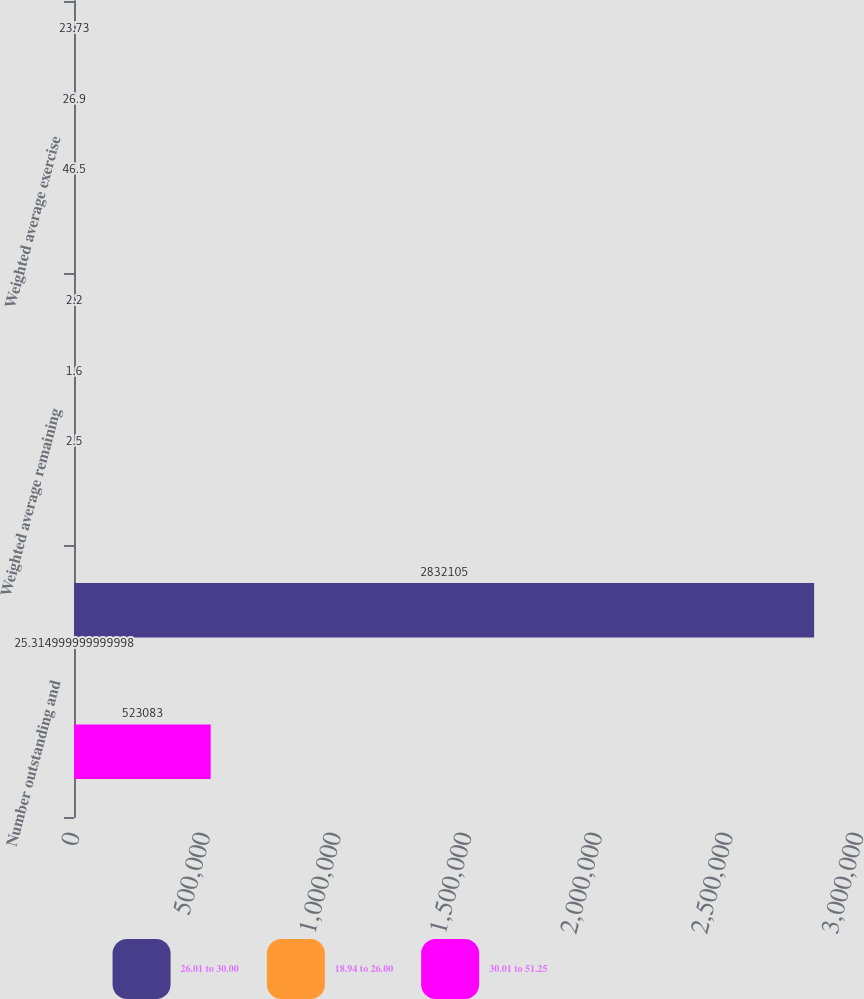Convert chart. <chart><loc_0><loc_0><loc_500><loc_500><stacked_bar_chart><ecel><fcel>Number outstanding and<fcel>Weighted average remaining<fcel>Weighted average exercise<nl><fcel>26.01 to 30.00<fcel>2.8321e+06<fcel>2.2<fcel>23.73<nl><fcel>18.94 to 26.00<fcel>25.315<fcel>1.6<fcel>26.9<nl><fcel>30.01 to 51.25<fcel>523083<fcel>2.5<fcel>46.5<nl></chart> 